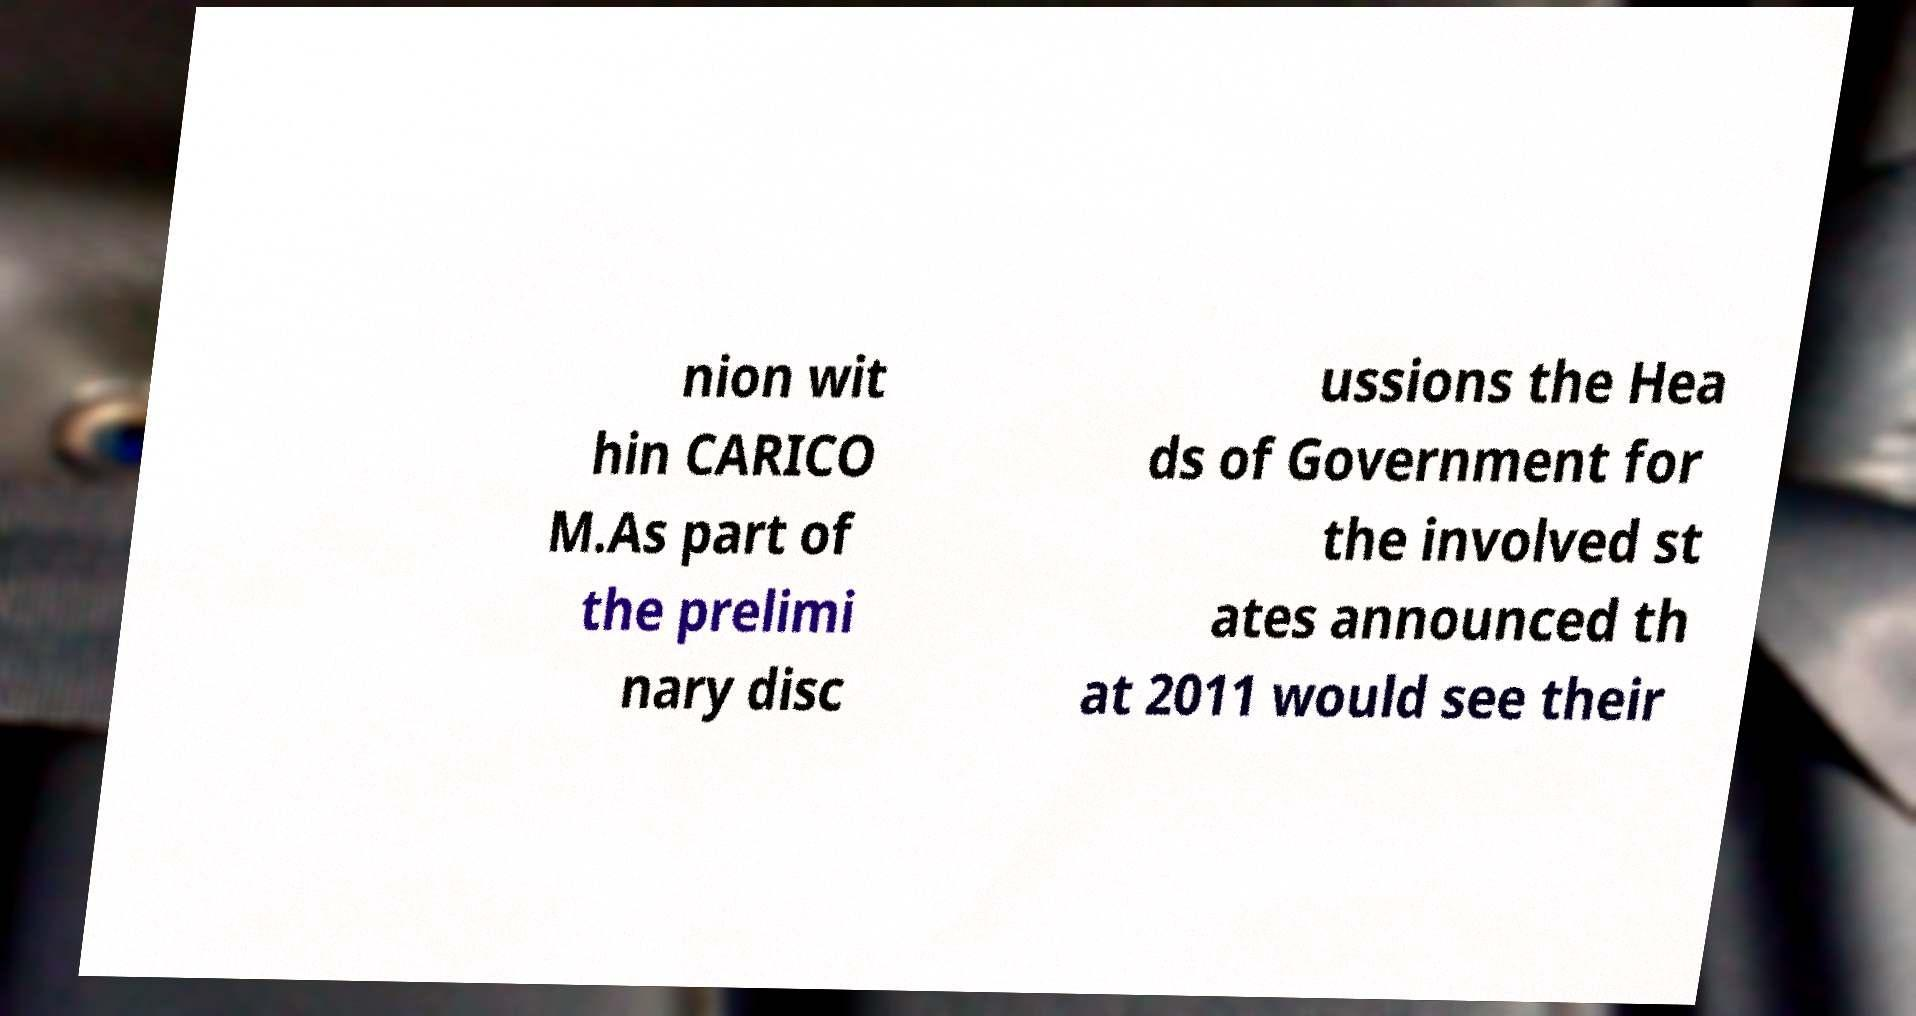Please read and relay the text visible in this image. What does it say? nion wit hin CARICO M.As part of the prelimi nary disc ussions the Hea ds of Government for the involved st ates announced th at 2011 would see their 